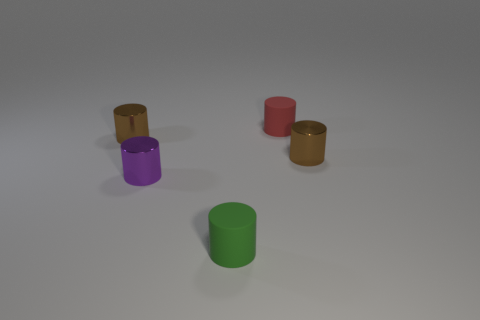Subtract 2 cylinders. How many cylinders are left? 3 Subtract all red cylinders. How many cylinders are left? 4 Subtract all yellow cylinders. Subtract all green blocks. How many cylinders are left? 5 Add 3 balls. How many objects exist? 8 Add 3 small brown cylinders. How many small brown cylinders are left? 5 Add 4 tiny matte cylinders. How many tiny matte cylinders exist? 6 Subtract 0 blue cylinders. How many objects are left? 5 Subtract all small metallic cylinders. Subtract all brown metallic cylinders. How many objects are left? 0 